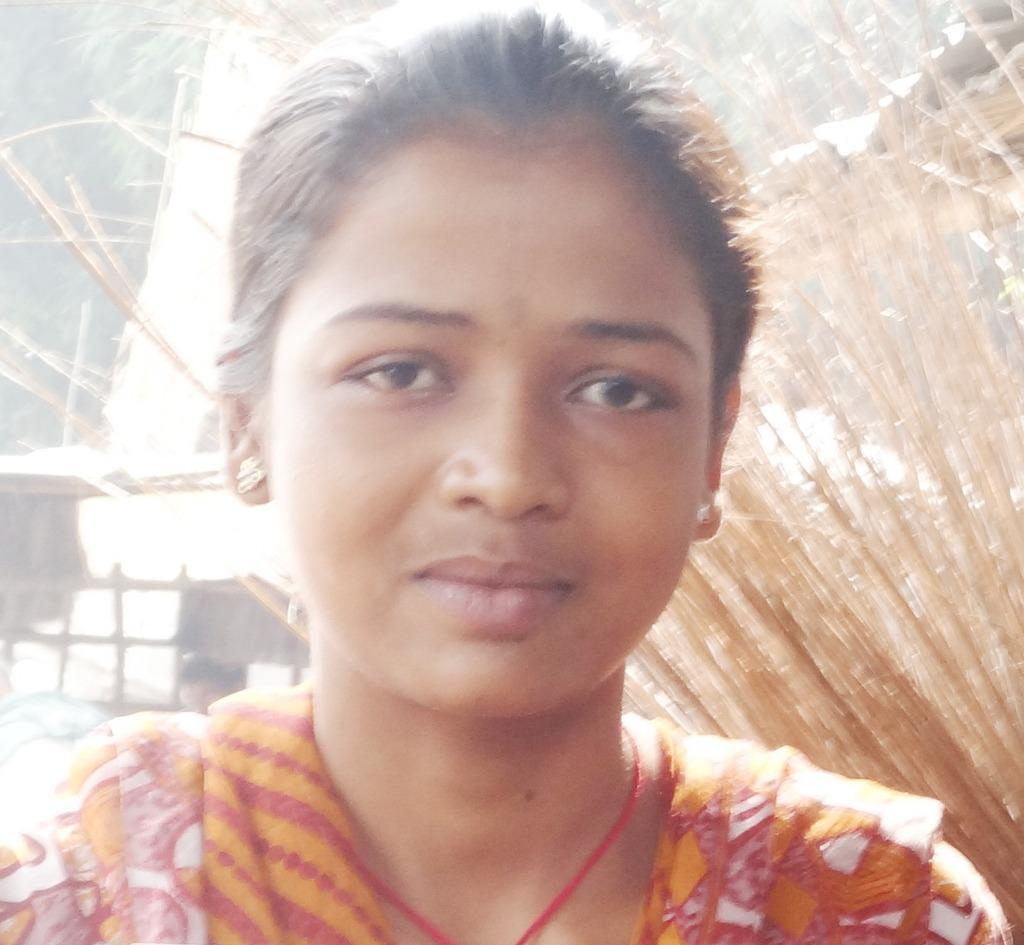What is the main subject in the foreground of the image? There is a girl standing in the foreground of the image. What type of materials can be seen in the background of the image? There are wooden boards and wooden sticks in the background of the image. What type of natural elements are visible in the background of the image? There are trees in the background of the image. What direction is the alarm pointing in the image? There is no alarm present in the image. How is the waste being managed in the image? There is no mention of waste in the image. 